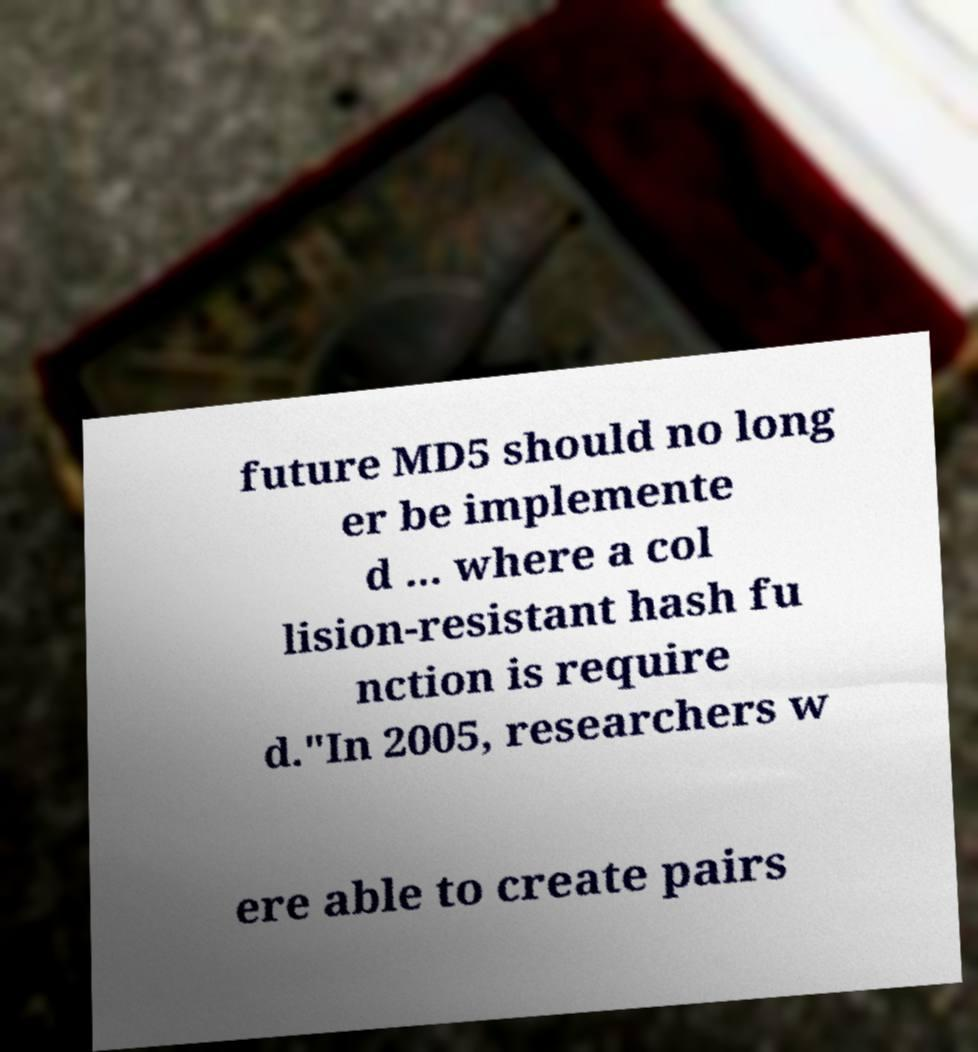Could you assist in decoding the text presented in this image and type it out clearly? future MD5 should no long er be implemente d ... where a col lision-resistant hash fu nction is require d."In 2005, researchers w ere able to create pairs 